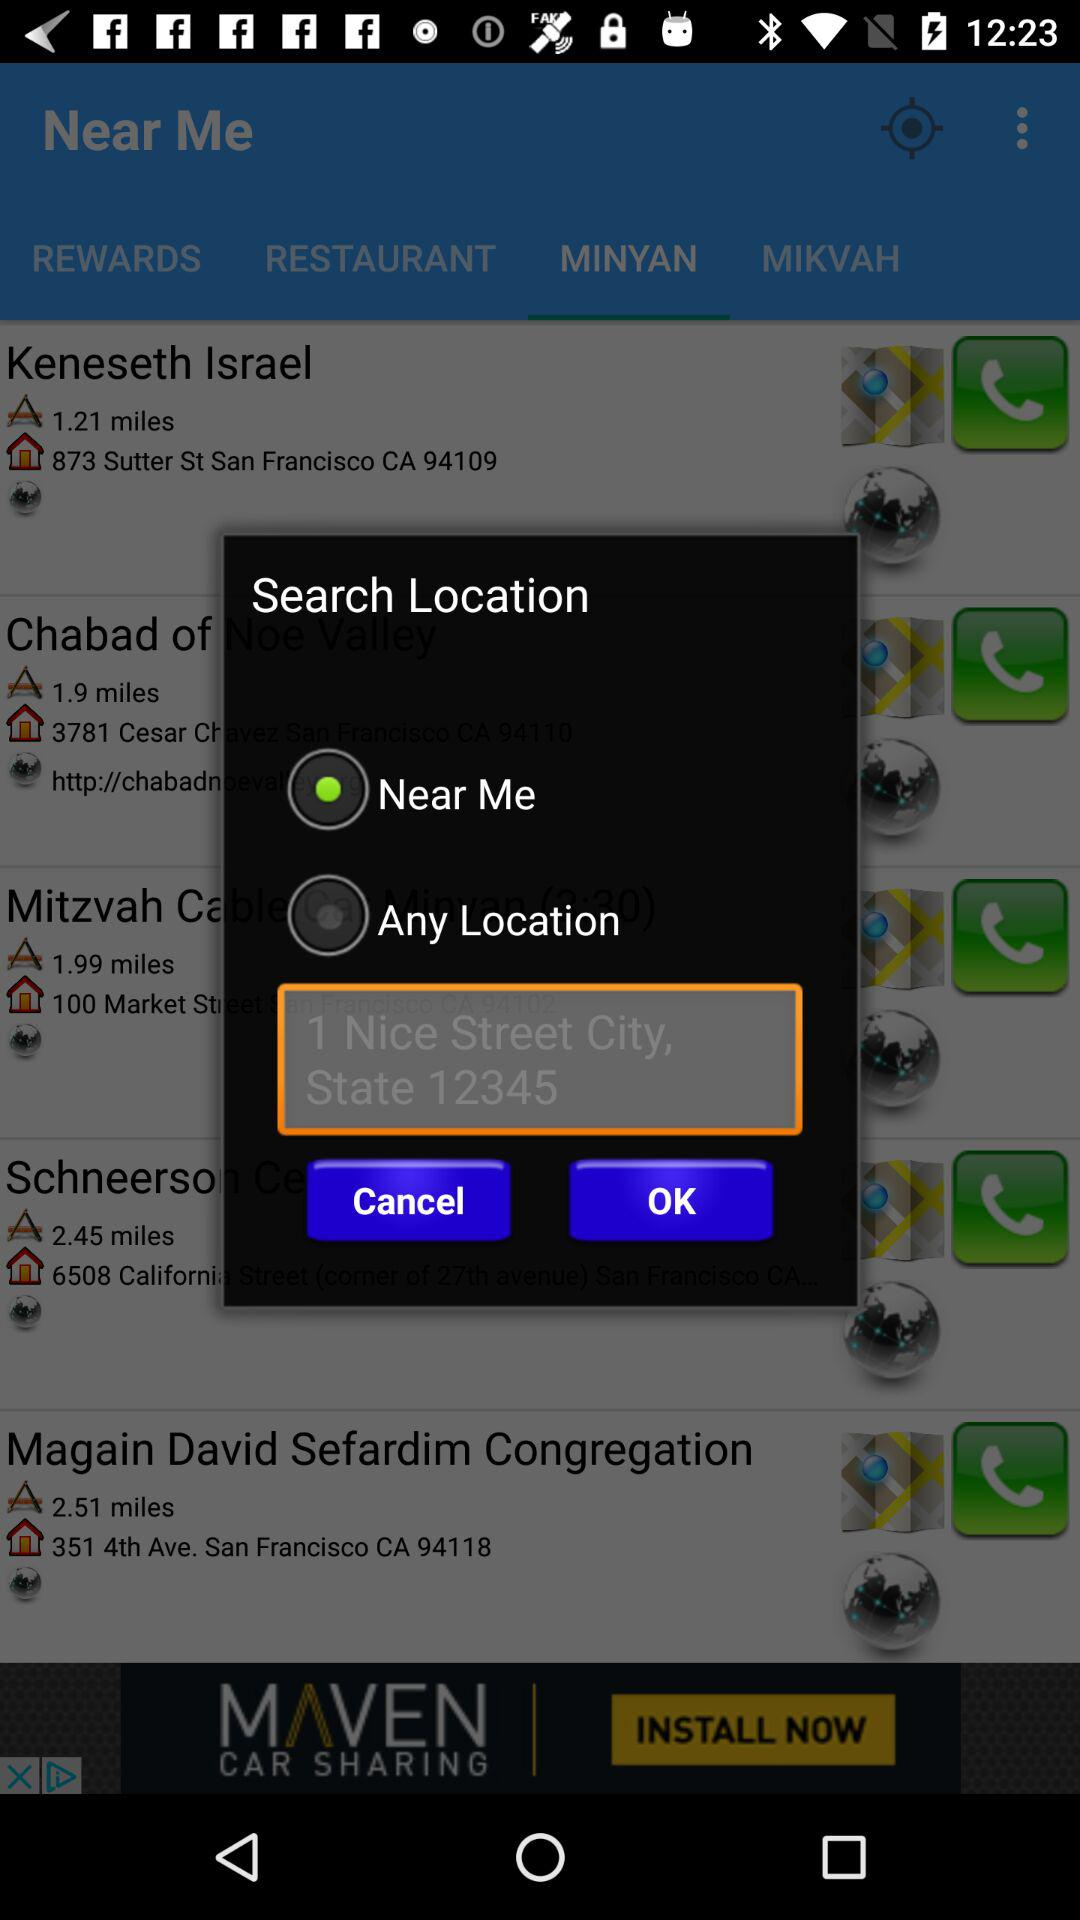Which radio button is selected? The selected radio button is "Near Me". 